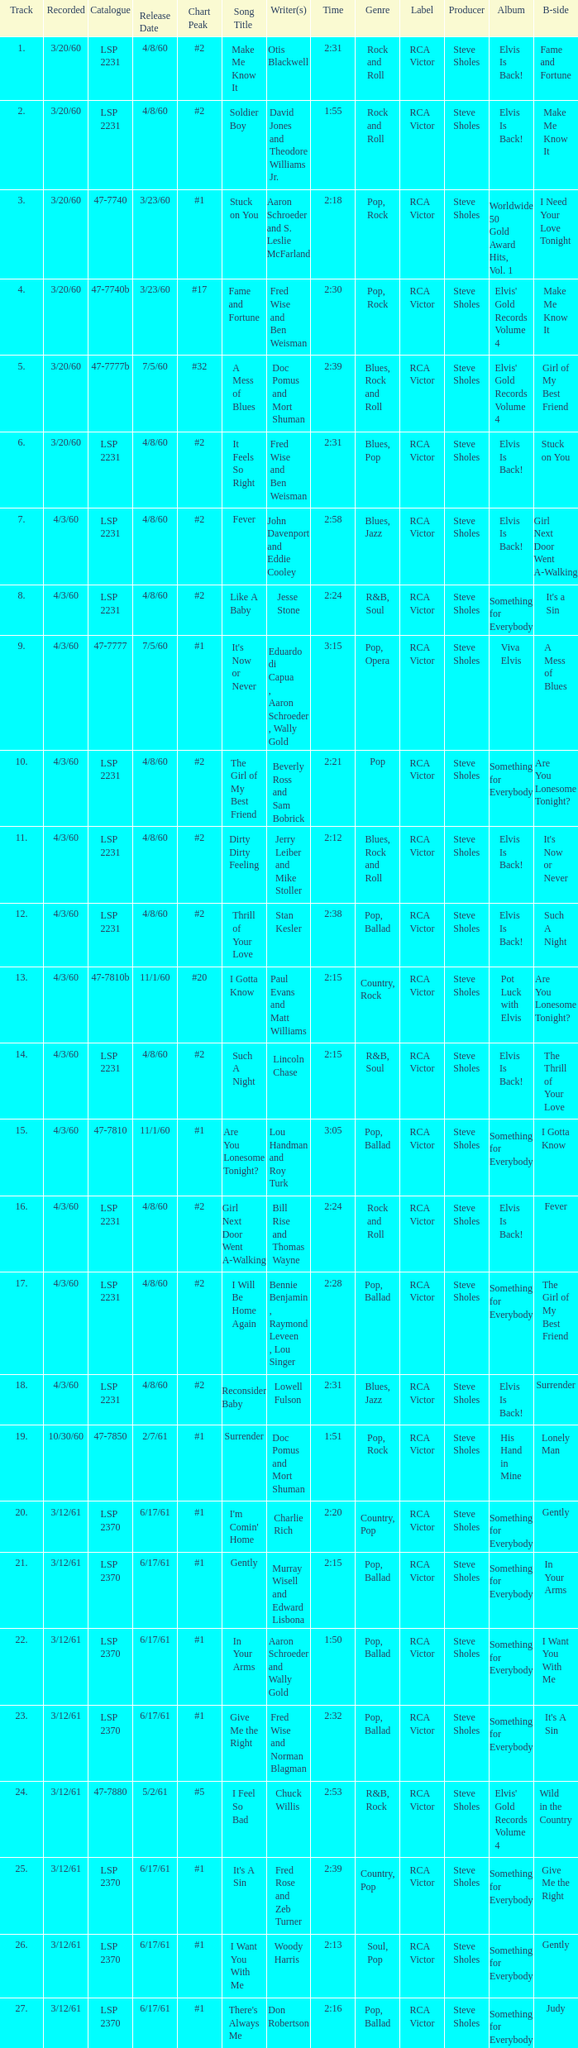On songs with track numbers smaller than number 17 and catalogues of LSP 2231, who are the writer(s)? Otis Blackwell, David Jones and Theodore Williams Jr., Fred Wise and Ben Weisman, John Davenport and Eddie Cooley, Jesse Stone, Beverly Ross and Sam Bobrick, Jerry Leiber and Mike Stoller, Stan Kesler, Lincoln Chase, Bill Rise and Thomas Wayne. 